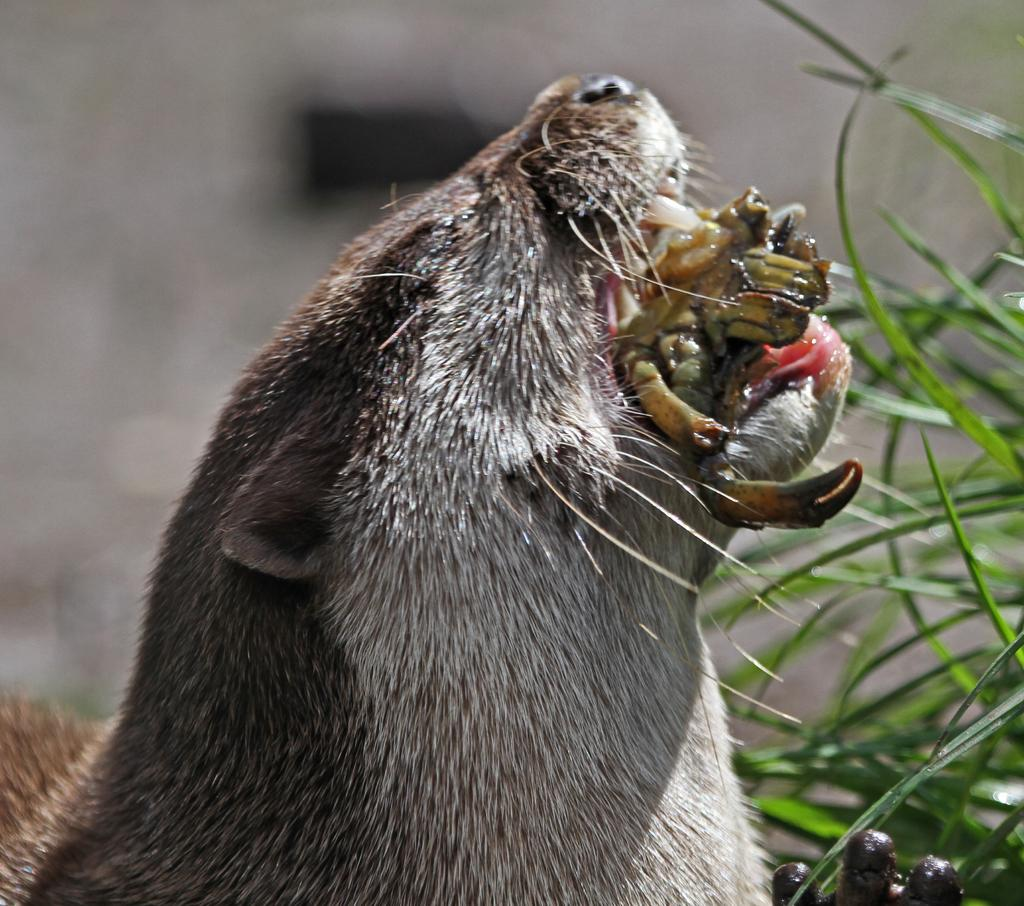What type of animal can be seen in the image? There is an animal in the image, but its specific type cannot be determined from the provided facts. What is the animal doing in the image? The animal is eating food in the image. What type of vegetation is on the right side of the image? There is grass on the right side of the image. How would you describe the background of the image? The background of the image is blurry. What type of curve can be seen in the animal's fur in the image? There is no curve visible in the animal's fur in the image, as the specific type of animal cannot be determined from the provided facts. 